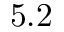Convert formula to latex. <formula><loc_0><loc_0><loc_500><loc_500>5 . 2</formula> 